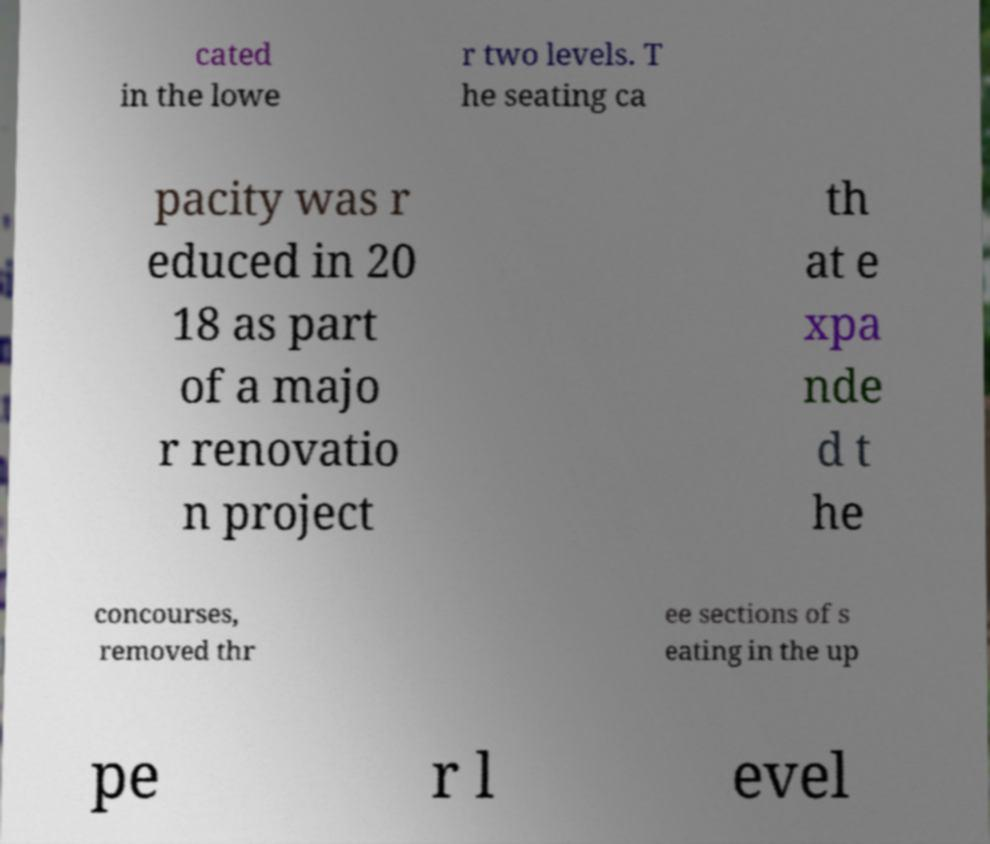I need the written content from this picture converted into text. Can you do that? cated in the lowe r two levels. T he seating ca pacity was r educed in 20 18 as part of a majo r renovatio n project th at e xpa nde d t he concourses, removed thr ee sections of s eating in the up pe r l evel 